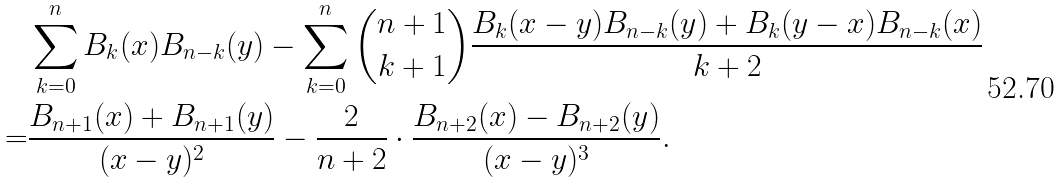Convert formula to latex. <formula><loc_0><loc_0><loc_500><loc_500>& \sum _ { k = 0 } ^ { n } B _ { k } ( x ) B _ { n - k } ( y ) - \sum _ { k = 0 } ^ { n } \binom { n + 1 } { k + 1 } \frac { B _ { k } ( x - y ) B _ { n - k } ( y ) + B _ { k } ( y - x ) B _ { n - k } ( x ) } { k + 2 } \\ = & \frac { B _ { n + 1 } ( x ) + B _ { n + 1 } ( y ) } { ( x - y ) ^ { 2 } } - \frac { 2 } { n + 2 } \cdot \frac { B _ { n + 2 } ( x ) - B _ { n + 2 } ( y ) } { ( x - y ) ^ { 3 } } .</formula> 